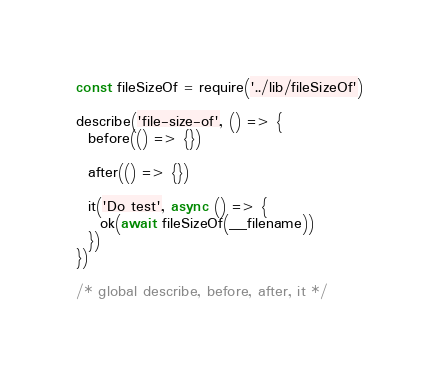<code> <loc_0><loc_0><loc_500><loc_500><_JavaScript_>const fileSizeOf = require('../lib/fileSizeOf')

describe('file-size-of', () => {
  before(() => {})

  after(() => {})

  it('Do test', async () => {
    ok(await fileSizeOf(__filename))
  })
})

/* global describe, before, after, it */
</code> 